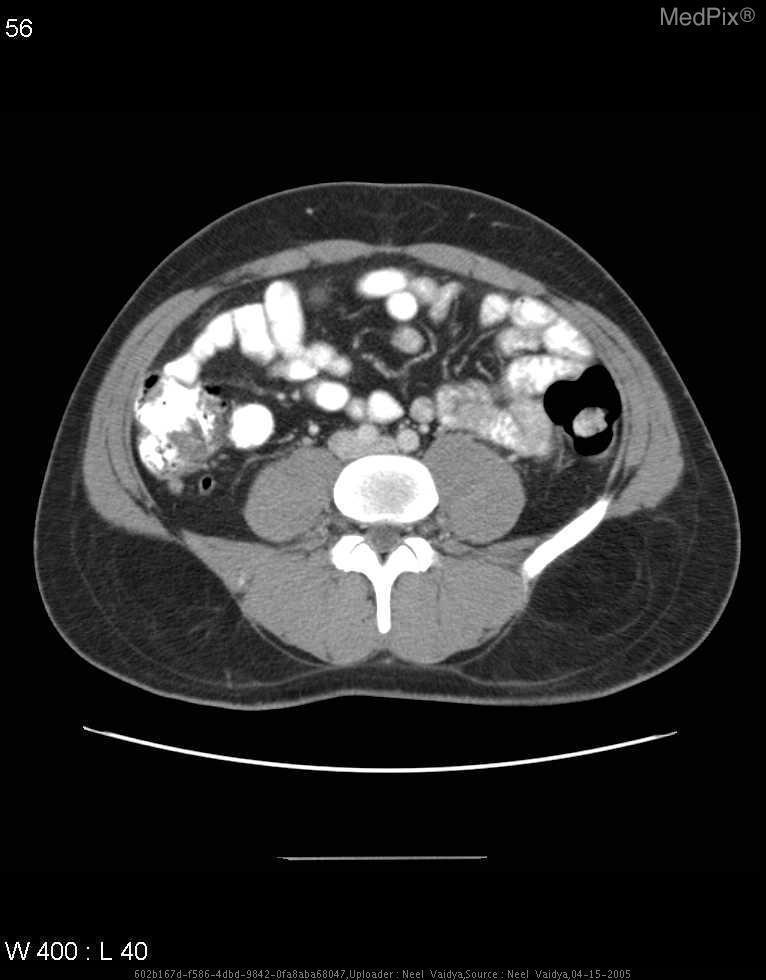Is there evidence of free peritoneal fluid?
Concise answer only. No. Does the appendix appear normal or abnormal?
Give a very brief answer. Normal. Is there appendix normal or abnormal in appearance?
Write a very short answer. Normal. What type of plane is this image of?
Keep it brief. Axial. What plane was this image taken in?
Short answer required. Axial. What contrast was administered to this patient?
Short answer required. Oral and iv. What types of contrast does this patient have?
Give a very brief answer. Oral and iv. 